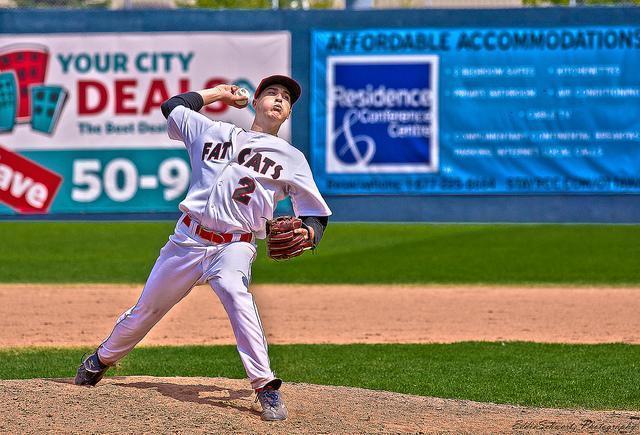How many people are in the picture?
Give a very brief answer. 1. How many cars in the shot?
Give a very brief answer. 0. 